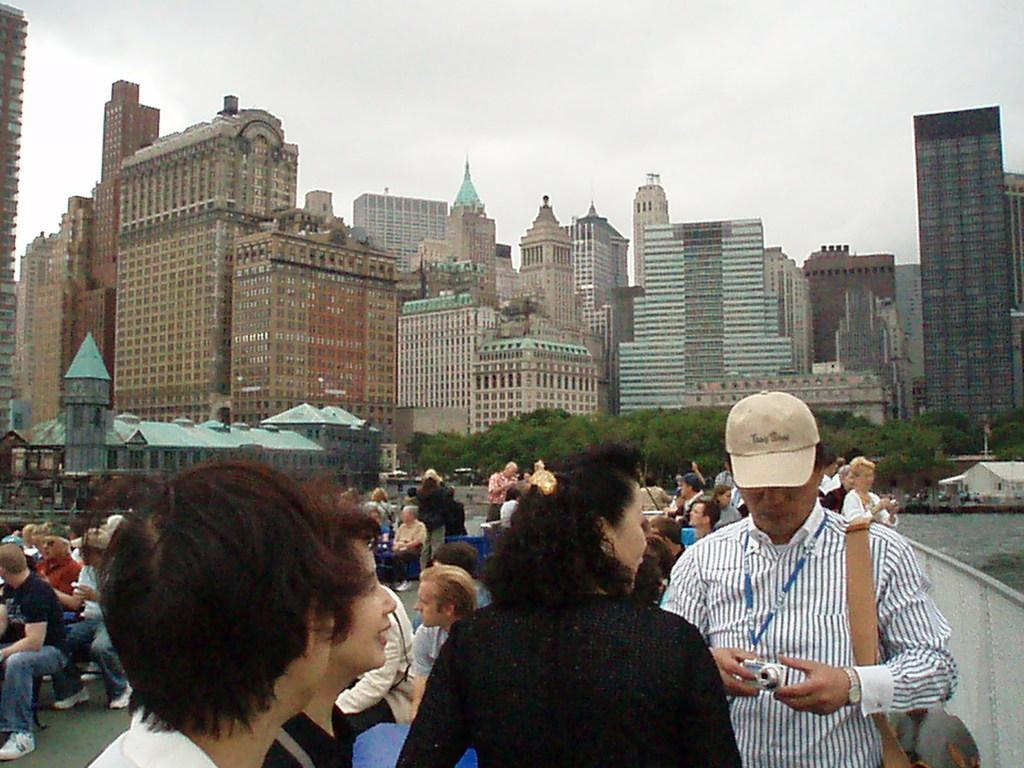Please provide a concise description of this image. This is an outside view. At the bottom there are few people standing. On the left side, I can see a crowd of people sitting on the chairs. On the right side there is a lake. In the background there are many buildings and trees. At the top of the image I can see the sky. 